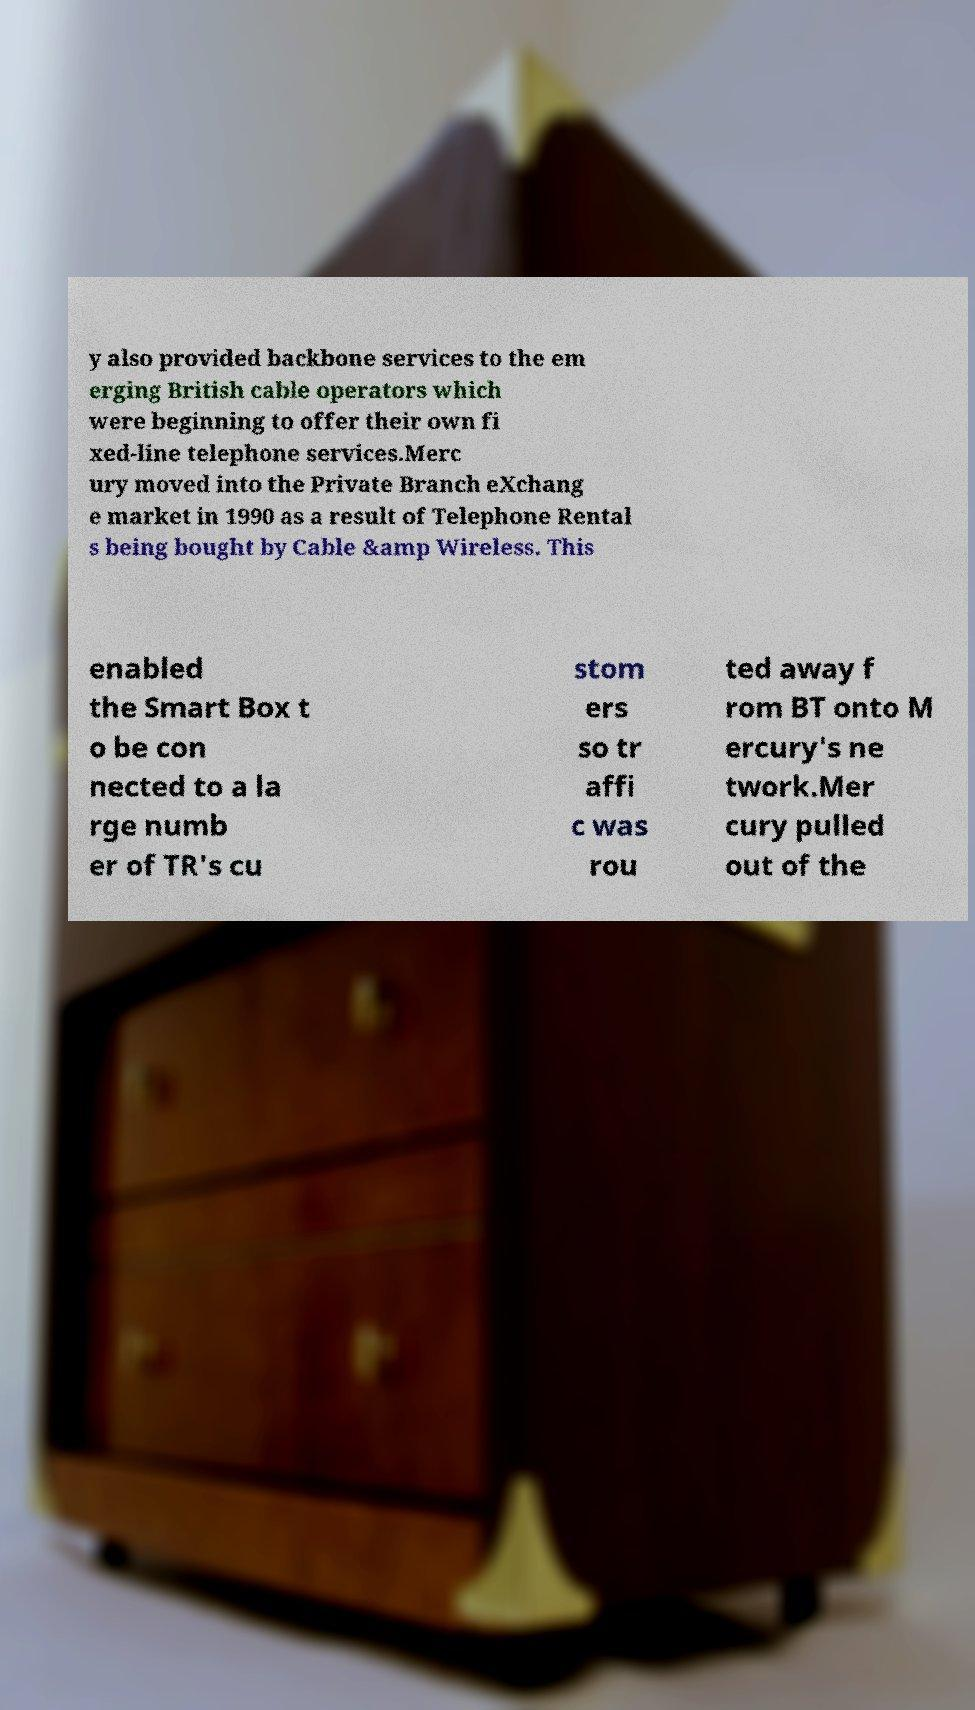Please identify and transcribe the text found in this image. y also provided backbone services to the em erging British cable operators which were beginning to offer their own fi xed-line telephone services.Merc ury moved into the Private Branch eXchang e market in 1990 as a result of Telephone Rental s being bought by Cable &amp Wireless. This enabled the Smart Box t o be con nected to a la rge numb er of TR's cu stom ers so tr affi c was rou ted away f rom BT onto M ercury's ne twork.Mer cury pulled out of the 